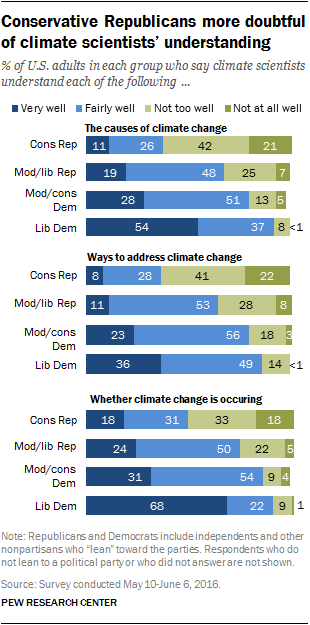Highlight a few significant elements in this photo. The number of colored bars used to represent the graph is four. The sum of all the navy blue bars is greater than the largest light blue bar. 